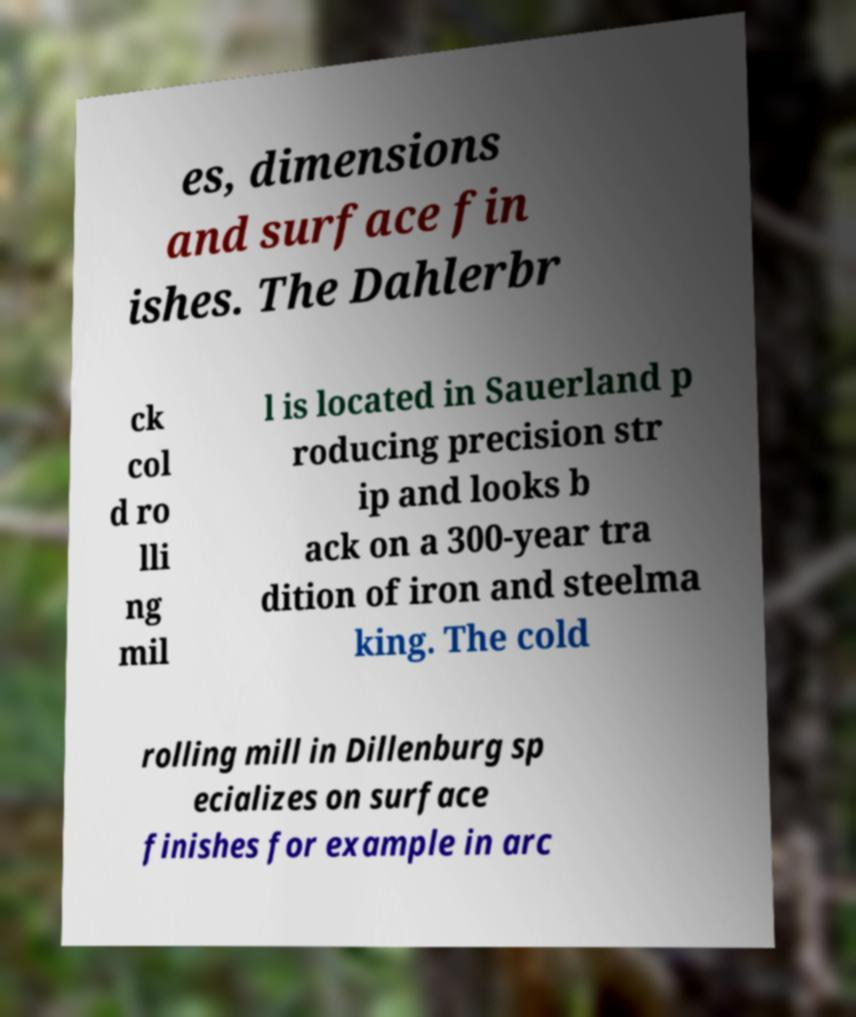There's text embedded in this image that I need extracted. Can you transcribe it verbatim? es, dimensions and surface fin ishes. The Dahlerbr ck col d ro lli ng mil l is located in Sauerland p roducing precision str ip and looks b ack on a 300-year tra dition of iron and steelma king. The cold rolling mill in Dillenburg sp ecializes on surface finishes for example in arc 